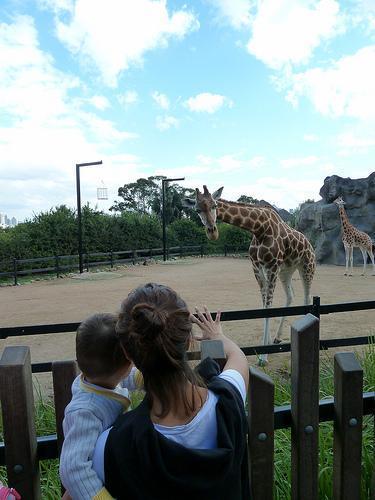How many people are there?
Give a very brief answer. 2. 